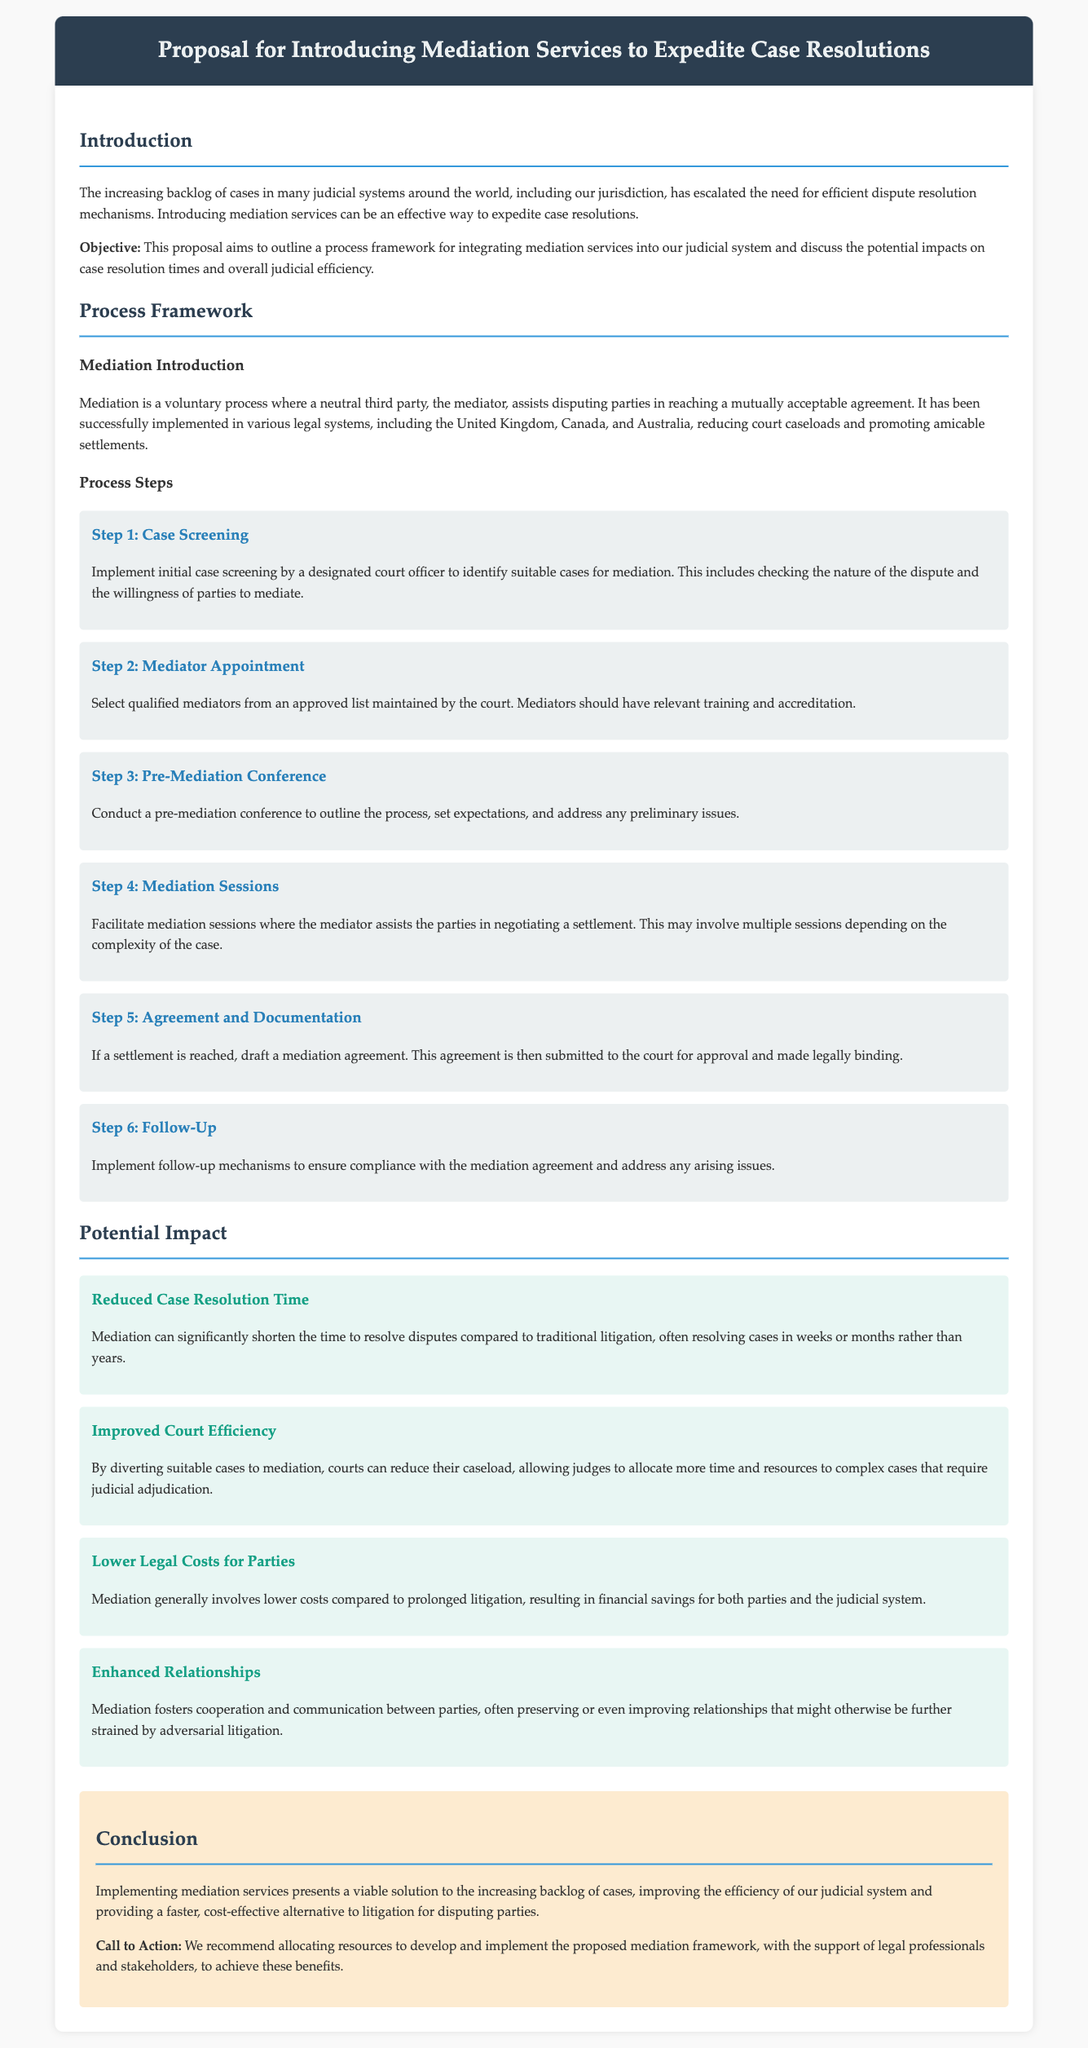What is the primary objective of the proposal? The objective is to outline a process framework for integrating mediation services into the judicial system and discuss the potential impacts on case resolution times and overall judicial efficiency.
Answer: Outline a process framework for integrating mediation services and discuss potential impacts What is the first step in the mediation process? The first step involves implementing initial case screening by a designated court officer to identify suitable cases for mediation.
Answer: Case Screening Which countries are mentioned as having successfully implemented mediation? The document mentions the United Kingdom, Canada, and Australia as countries where mediation has been successfully implemented.
Answer: United Kingdom, Canada, and Australia How does mediation impact case resolution time? Mediation can significantly shorten the time to resolve disputes compared to traditional litigation, often resolving cases in weeks or months rather than years.
Answer: Significantly shorter time What is one potential impact of implementing mediation services on court efficiency? By diverting suitable cases to mediation, courts can reduce their caseload, allowing judges to allocate more time and resources to complex cases that require judicial adjudication.
Answer: Reduce case backlog What is the last section of the document called? The last section of the document is called "Conclusion."
Answer: Conclusion What is recommended for the successful implementation of mediation services? It is recommended to allocate resources to develop and implement the proposed mediation framework.
Answer: Allocate resources How does mediation benefit parties financially? Mediation generally involves lower costs compared to prolonged litigation, resulting in financial savings for both parties and the judicial system.
Answer: Lower costs compared to litigation What is a potential benefit of mediation for relationships between parties? Mediation fosters cooperation and communication between parties, often preserving or even improving relationships.
Answer: Preserving or improving relationships 